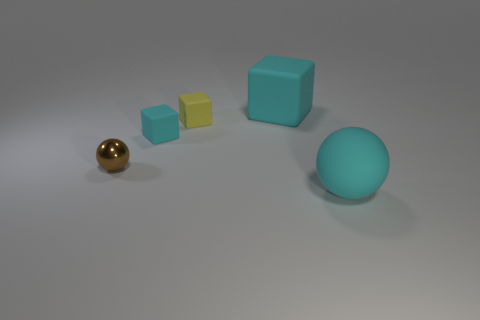Add 4 green metallic things. How many objects exist? 9 Subtract all blocks. How many objects are left? 2 Subtract 0 gray cylinders. How many objects are left? 5 Subtract all big gray metallic things. Subtract all cubes. How many objects are left? 2 Add 5 tiny cyan cubes. How many tiny cyan cubes are left? 6 Add 1 big cyan things. How many big cyan things exist? 3 